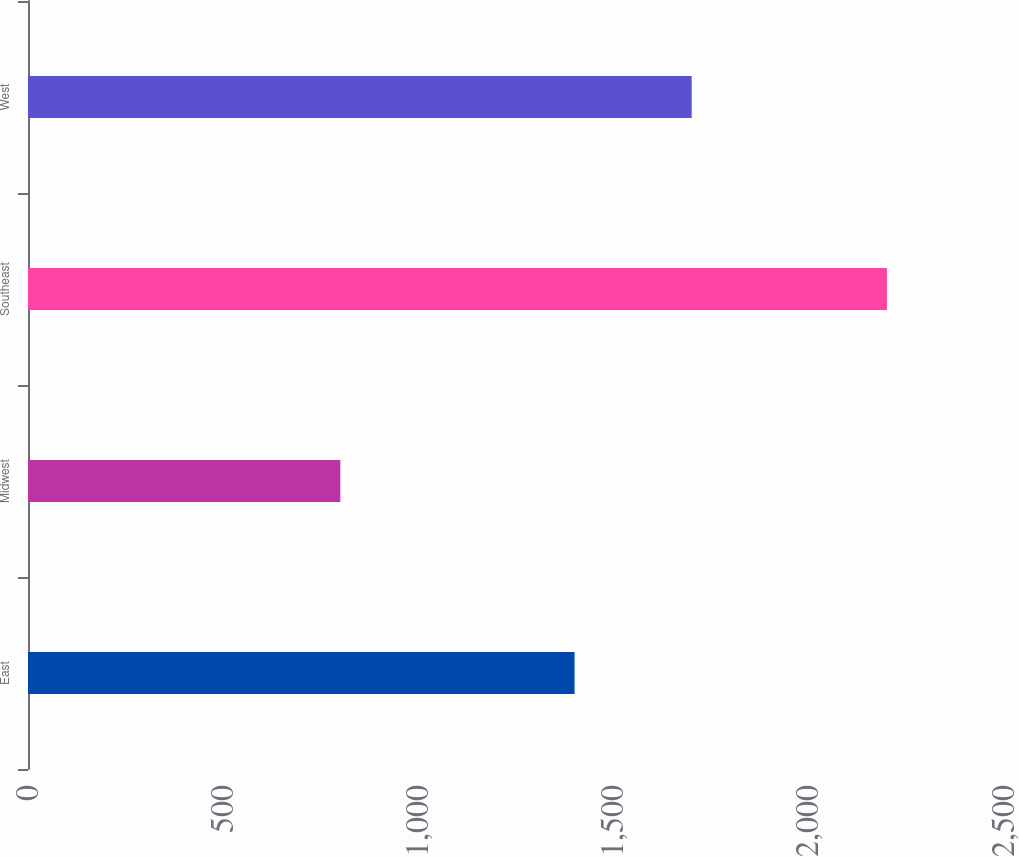<chart> <loc_0><loc_0><loc_500><loc_500><bar_chart><fcel>East<fcel>Midwest<fcel>Southeast<fcel>West<nl><fcel>1400<fcel>800<fcel>2200<fcel>1700<nl></chart> 